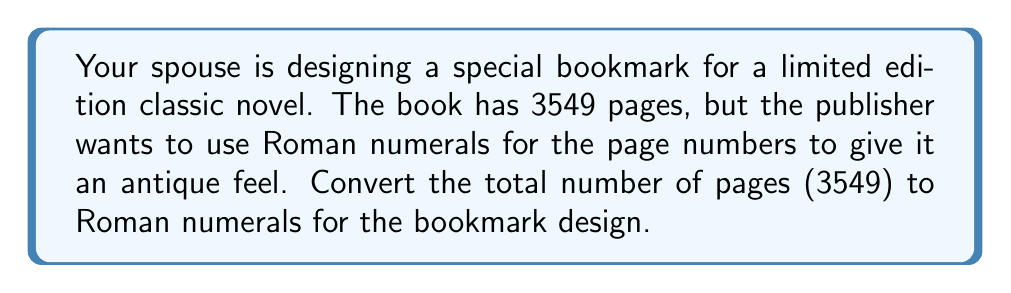Give your solution to this math problem. To convert 3549 to Roman numerals, we need to break it down into place values and convert each place value to its Roman numeral equivalent. Let's do this step by step:

1) First, let's break 3549 into place values:
   $3549 = 3000 + 500 + 40 + 9$

2) Now, let's convert each place value to Roman numerals:

   3000 = MMM (1000 is M, so 3000 is MMM)
   500 = D
   40 = XL (50 is L, but we need 40, so we use XL which is 50-10)
   9 = IX (10 is X, but we need 9, so we use IX which is 10-1)

3) Combining these Roman numerals in order from largest to smallest:

   $3549 = \text{MMM} + \text{D} + \text{XL} + \text{IX}$

4) Therefore, the final Roman numeral representation is:

   $3549 = \text{MMMDXLIX}$

Note: In Roman numerals, we write the symbols from left to right in descending order of value, except where subtraction is used (like XL for 40 and IX for 9).
Answer: MMMDXLIX 